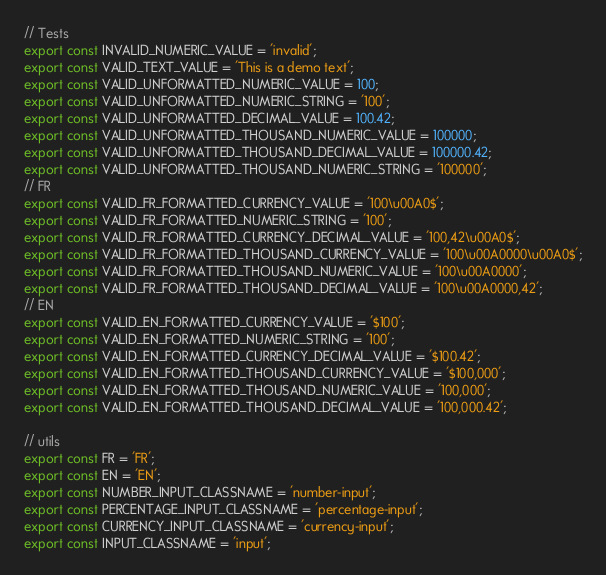<code> <loc_0><loc_0><loc_500><loc_500><_JavaScript_>// Tests
export const INVALID_NUMERIC_VALUE = 'invalid';
export const VALID_TEXT_VALUE = 'This is a demo text';
export const VALID_UNFORMATTED_NUMERIC_VALUE = 100;
export const VALID_UNFORMATTED_NUMERIC_STRING = '100';
export const VALID_UNFORMATTED_DECIMAL_VALUE = 100.42;
export const VALID_UNFORMATTED_THOUSAND_NUMERIC_VALUE = 100000;
export const VALID_UNFORMATTED_THOUSAND_DECIMAL_VALUE = 100000.42;
export const VALID_UNFORMATTED_THOUSAND_NUMERIC_STRING = '100000';
// FR
export const VALID_FR_FORMATTED_CURRENCY_VALUE = '100\u00A0$';
export const VALID_FR_FORMATTED_NUMERIC_STRING = '100';
export const VALID_FR_FORMATTED_CURRENCY_DECIMAL_VALUE = '100,42\u00A0$';
export const VALID_FR_FORMATTED_THOUSAND_CURRENCY_VALUE = '100\u00A0000\u00A0$';
export const VALID_FR_FORMATTED_THOUSAND_NUMERIC_VALUE = '100\u00A0000';
export const VALID_FR_FORMATTED_THOUSAND_DECIMAL_VALUE = '100\u00A0000,42';
// EN
export const VALID_EN_FORMATTED_CURRENCY_VALUE = '$100';
export const VALID_EN_FORMATTED_NUMERIC_STRING = '100';
export const VALID_EN_FORMATTED_CURRENCY_DECIMAL_VALUE = '$100.42';
export const VALID_EN_FORMATTED_THOUSAND_CURRENCY_VALUE = '$100,000';
export const VALID_EN_FORMATTED_THOUSAND_NUMERIC_VALUE = '100,000';
export const VALID_EN_FORMATTED_THOUSAND_DECIMAL_VALUE = '100,000.42';

// utils
export const FR = 'FR';
export const EN = 'EN';
export const NUMBER_INPUT_CLASSNAME = 'number-input';
export const PERCENTAGE_INPUT_CLASSNAME = 'percentage-input';
export const CURRENCY_INPUT_CLASSNAME = 'currency-input';
export const INPUT_CLASSNAME = 'input';
</code> 